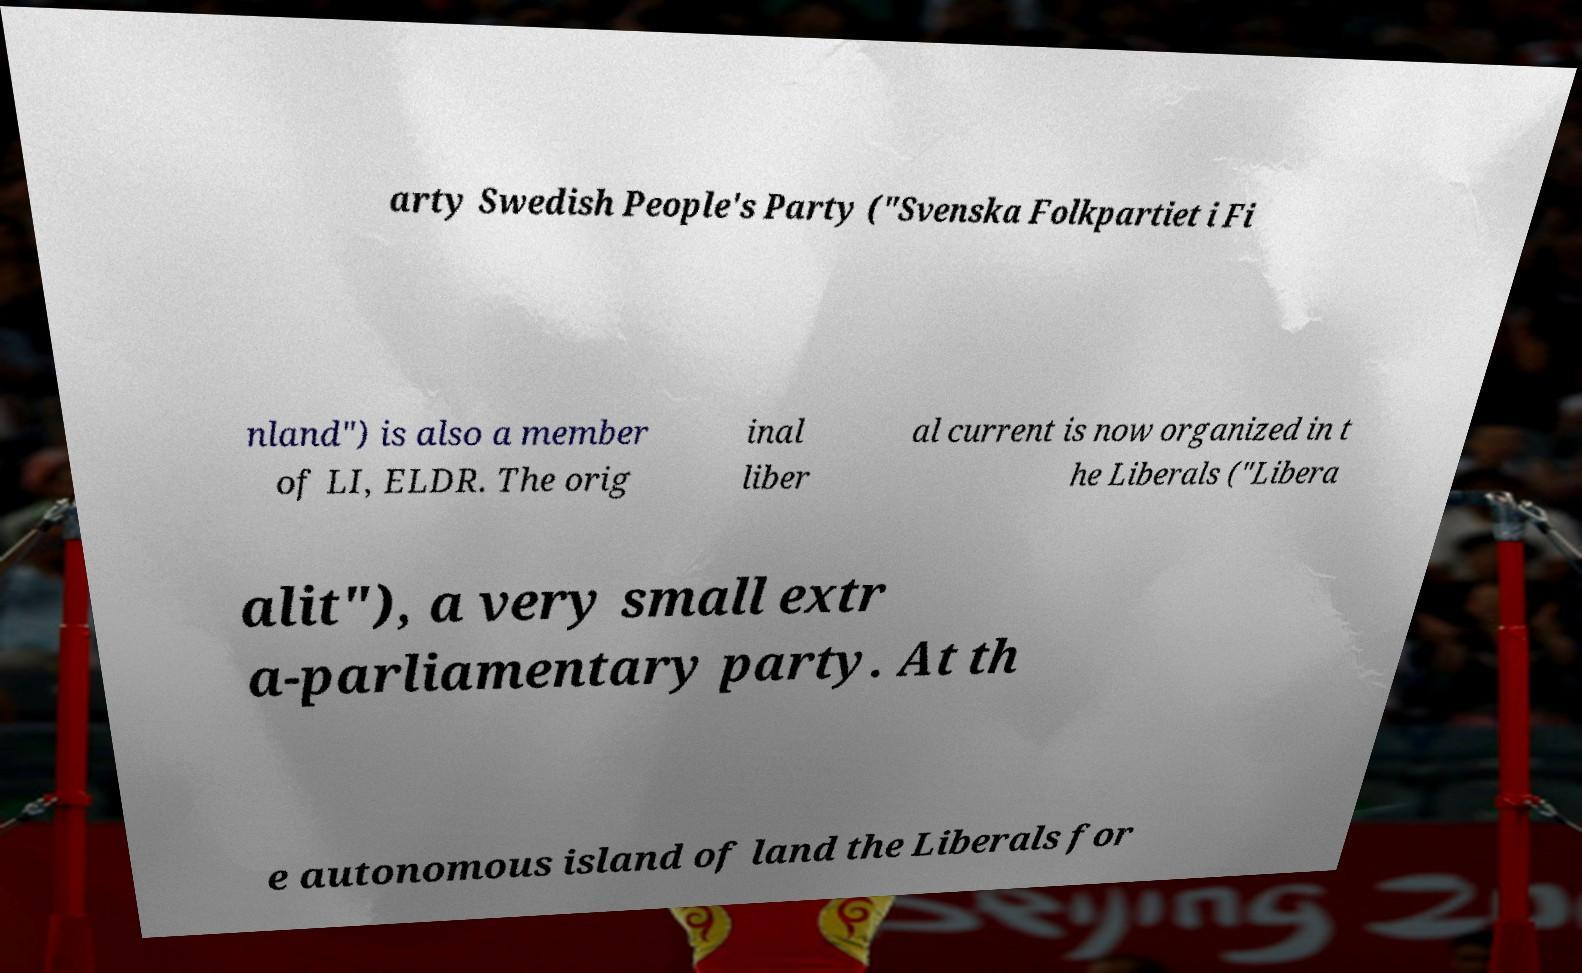What messages or text are displayed in this image? I need them in a readable, typed format. arty Swedish People's Party ("Svenska Folkpartiet i Fi nland") is also a member of LI, ELDR. The orig inal liber al current is now organized in t he Liberals ("Libera alit"), a very small extr a-parliamentary party. At th e autonomous island of land the Liberals for 